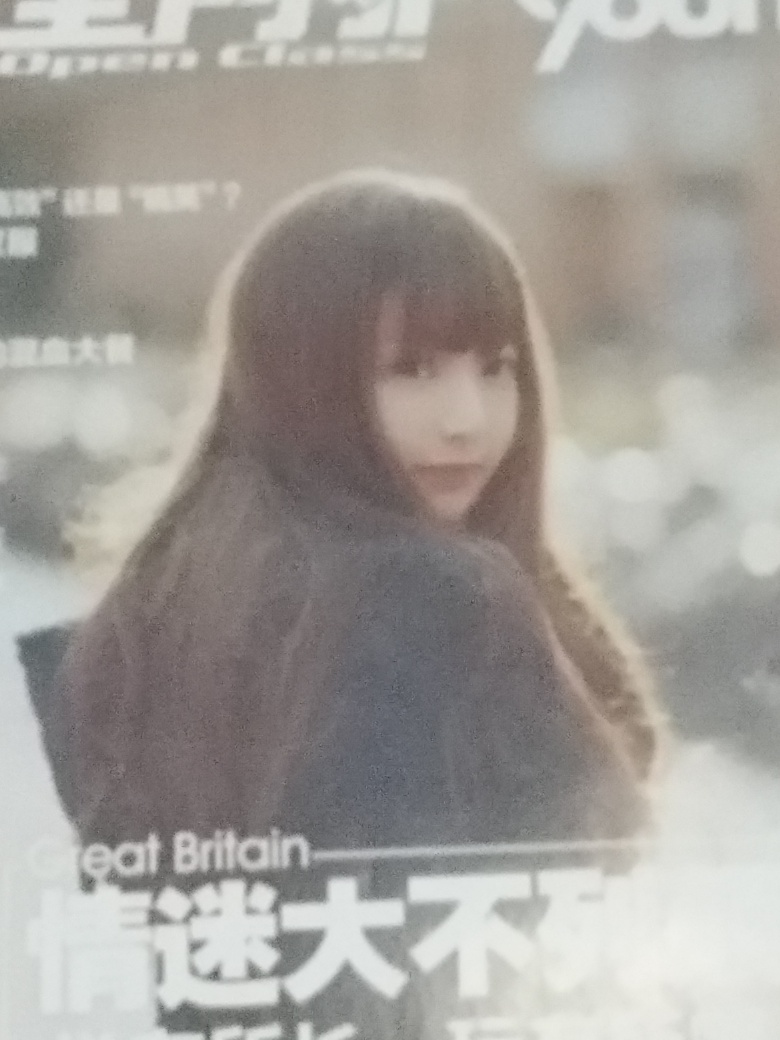Delve into the quality of the photograph and give a verdict based on your scrutiny.
 The overall image clarity of this image is very low, there is a serious focus problem, there is severe noise, the lighting is sufficient, the colors are monotonous, the subject is a portrait, it is very blurry, all texture details are lost, the composition is flat, and the background is very blurry. Therefore, the quality of this image is very poor. 